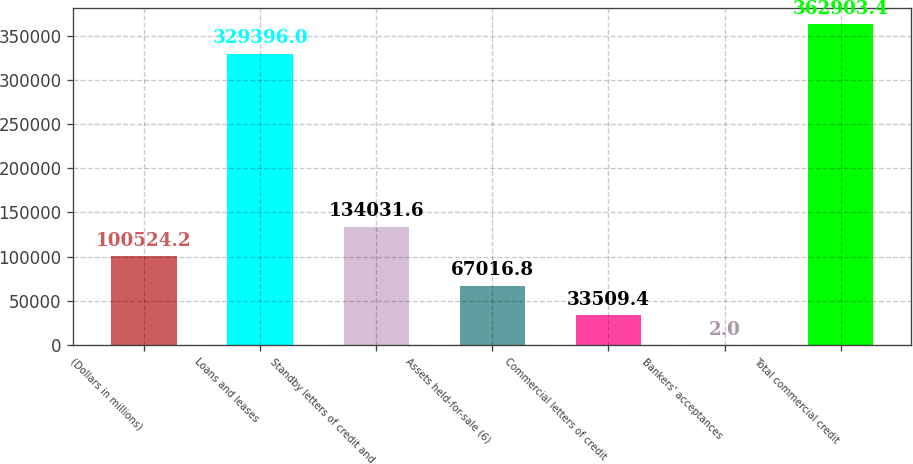Convert chart. <chart><loc_0><loc_0><loc_500><loc_500><bar_chart><fcel>(Dollars in millions)<fcel>Loans and leases<fcel>Standby letters of credit and<fcel>Assets held-for-sale (6)<fcel>Commercial letters of credit<fcel>Bankers' acceptances<fcel>Total commercial credit<nl><fcel>100524<fcel>329396<fcel>134032<fcel>67016.8<fcel>33509.4<fcel>2<fcel>362903<nl></chart> 